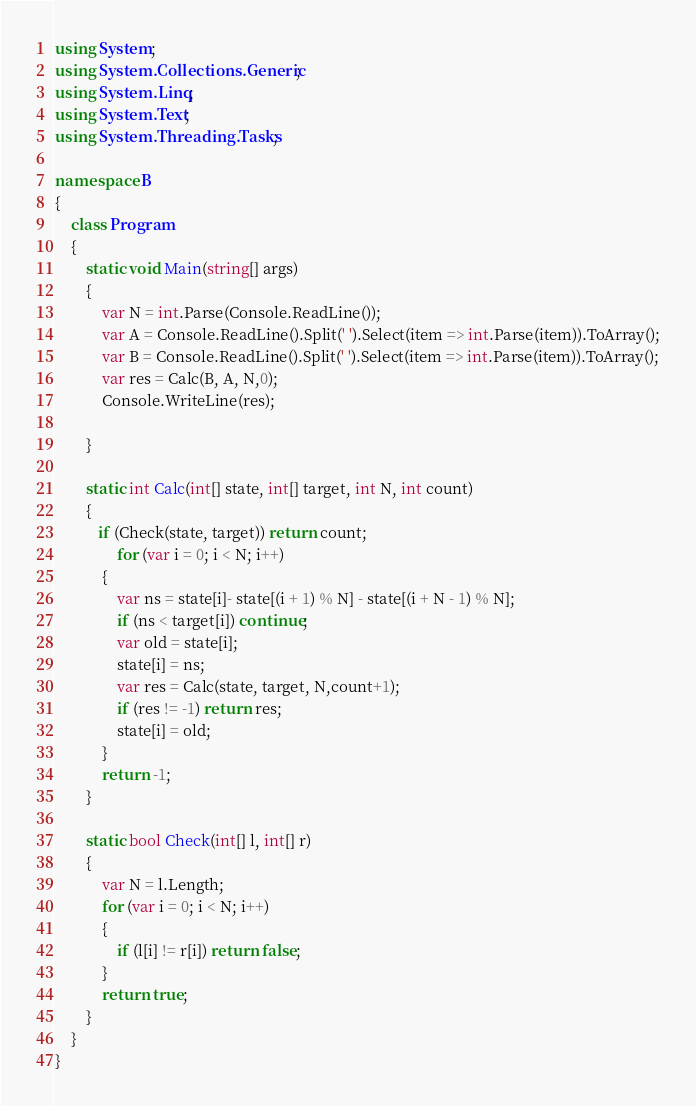Convert code to text. <code><loc_0><loc_0><loc_500><loc_500><_C#_>using System;
using System.Collections.Generic;
using System.Linq;
using System.Text;
using System.Threading.Tasks;

namespace B
{
    class Program
    {
        static void Main(string[] args)
        {
            var N = int.Parse(Console.ReadLine());
            var A = Console.ReadLine().Split(' ').Select(item => int.Parse(item)).ToArray();
            var B = Console.ReadLine().Split(' ').Select(item => int.Parse(item)).ToArray();
            var res = Calc(B, A, N,0);
            Console.WriteLine(res);

        }

        static int Calc(int[] state, int[] target, int N, int count)
        {
           if (Check(state, target)) return count;
                for (var i = 0; i < N; i++)
            {
                var ns = state[i]- state[(i + 1) % N] - state[(i + N - 1) % N];
                if (ns < target[i]) continue;
                var old = state[i];
                state[i] = ns;
                var res = Calc(state, target, N,count+1);
                if (res != -1) return res;
                state[i] = old;
            }
            return -1;
        }

        static bool Check(int[] l, int[] r)
        {
            var N = l.Length;
            for (var i = 0; i < N; i++)
            {
                if (l[i] != r[i]) return false;
            }
            return true;
        }
    }
}
</code> 